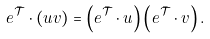<formula> <loc_0><loc_0><loc_500><loc_500>e ^ { \bar { \mathcal { T } } } \cdot ( u v ) = \left ( e ^ { \bar { \mathcal { T } } } \cdot u \right ) \left ( e ^ { \bar { \mathcal { T } } } \cdot v \right ) .</formula> 